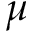Convert formula to latex. <formula><loc_0><loc_0><loc_500><loc_500>\mu</formula> 